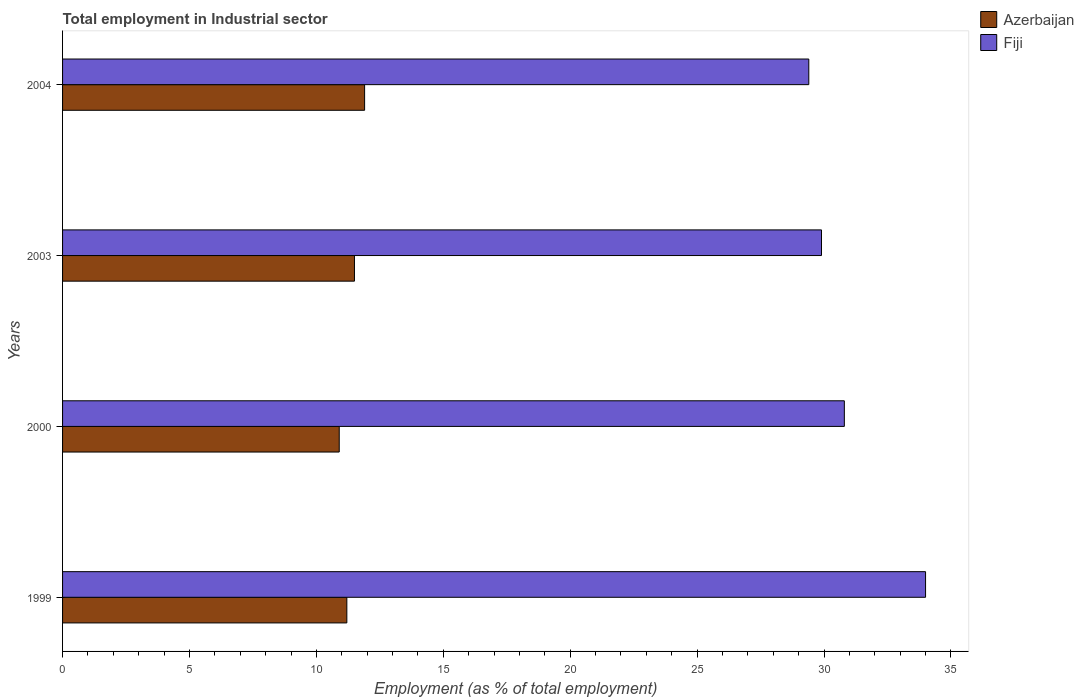How many different coloured bars are there?
Give a very brief answer. 2. Are the number of bars per tick equal to the number of legend labels?
Make the answer very short. Yes. Are the number of bars on each tick of the Y-axis equal?
Your answer should be compact. Yes. How many bars are there on the 1st tick from the bottom?
Offer a terse response. 2. In how many cases, is the number of bars for a given year not equal to the number of legend labels?
Your answer should be very brief. 0. What is the employment in industrial sector in Fiji in 2003?
Keep it short and to the point. 29.9. Across all years, what is the maximum employment in industrial sector in Fiji?
Offer a very short reply. 34. Across all years, what is the minimum employment in industrial sector in Fiji?
Keep it short and to the point. 29.4. What is the total employment in industrial sector in Fiji in the graph?
Provide a succinct answer. 124.1. What is the difference between the employment in industrial sector in Azerbaijan in 2000 and that in 2003?
Provide a succinct answer. -0.6. What is the difference between the employment in industrial sector in Azerbaijan in 2004 and the employment in industrial sector in Fiji in 1999?
Offer a terse response. -22.1. What is the average employment in industrial sector in Azerbaijan per year?
Provide a short and direct response. 11.37. In the year 2004, what is the difference between the employment in industrial sector in Fiji and employment in industrial sector in Azerbaijan?
Provide a succinct answer. 17.5. What is the ratio of the employment in industrial sector in Azerbaijan in 1999 to that in 2000?
Your answer should be very brief. 1.03. Is the employment in industrial sector in Azerbaijan in 2003 less than that in 2004?
Provide a succinct answer. Yes. Is the difference between the employment in industrial sector in Fiji in 1999 and 2004 greater than the difference between the employment in industrial sector in Azerbaijan in 1999 and 2004?
Give a very brief answer. Yes. What is the difference between the highest and the second highest employment in industrial sector in Fiji?
Keep it short and to the point. 3.2. What is the difference between the highest and the lowest employment in industrial sector in Azerbaijan?
Provide a short and direct response. 1. In how many years, is the employment in industrial sector in Azerbaijan greater than the average employment in industrial sector in Azerbaijan taken over all years?
Provide a succinct answer. 2. What does the 1st bar from the top in 2004 represents?
Offer a very short reply. Fiji. What does the 2nd bar from the bottom in 2004 represents?
Provide a short and direct response. Fiji. Are all the bars in the graph horizontal?
Ensure brevity in your answer.  Yes. How many years are there in the graph?
Provide a short and direct response. 4. What is the difference between two consecutive major ticks on the X-axis?
Provide a succinct answer. 5. Does the graph contain grids?
Provide a short and direct response. No. What is the title of the graph?
Your response must be concise. Total employment in Industrial sector. Does "Lithuania" appear as one of the legend labels in the graph?
Offer a terse response. No. What is the label or title of the X-axis?
Offer a terse response. Employment (as % of total employment). What is the label or title of the Y-axis?
Make the answer very short. Years. What is the Employment (as % of total employment) in Azerbaijan in 1999?
Offer a very short reply. 11.2. What is the Employment (as % of total employment) of Fiji in 1999?
Offer a terse response. 34. What is the Employment (as % of total employment) in Azerbaijan in 2000?
Provide a short and direct response. 10.9. What is the Employment (as % of total employment) in Fiji in 2000?
Ensure brevity in your answer.  30.8. What is the Employment (as % of total employment) in Fiji in 2003?
Your answer should be compact. 29.9. What is the Employment (as % of total employment) of Azerbaijan in 2004?
Offer a terse response. 11.9. What is the Employment (as % of total employment) in Fiji in 2004?
Your answer should be very brief. 29.4. Across all years, what is the maximum Employment (as % of total employment) of Azerbaijan?
Keep it short and to the point. 11.9. Across all years, what is the minimum Employment (as % of total employment) of Azerbaijan?
Your response must be concise. 10.9. Across all years, what is the minimum Employment (as % of total employment) of Fiji?
Give a very brief answer. 29.4. What is the total Employment (as % of total employment) in Azerbaijan in the graph?
Your answer should be compact. 45.5. What is the total Employment (as % of total employment) in Fiji in the graph?
Your answer should be compact. 124.1. What is the difference between the Employment (as % of total employment) of Fiji in 1999 and that in 2000?
Offer a very short reply. 3.2. What is the difference between the Employment (as % of total employment) of Fiji in 1999 and that in 2003?
Offer a very short reply. 4.1. What is the difference between the Employment (as % of total employment) in Fiji in 1999 and that in 2004?
Your answer should be very brief. 4.6. What is the difference between the Employment (as % of total employment) in Azerbaijan in 2000 and that in 2003?
Ensure brevity in your answer.  -0.6. What is the difference between the Employment (as % of total employment) in Fiji in 2000 and that in 2003?
Offer a very short reply. 0.9. What is the difference between the Employment (as % of total employment) of Fiji in 2000 and that in 2004?
Offer a very short reply. 1.4. What is the difference between the Employment (as % of total employment) of Azerbaijan in 1999 and the Employment (as % of total employment) of Fiji in 2000?
Provide a short and direct response. -19.6. What is the difference between the Employment (as % of total employment) of Azerbaijan in 1999 and the Employment (as % of total employment) of Fiji in 2003?
Your answer should be compact. -18.7. What is the difference between the Employment (as % of total employment) of Azerbaijan in 1999 and the Employment (as % of total employment) of Fiji in 2004?
Make the answer very short. -18.2. What is the difference between the Employment (as % of total employment) of Azerbaijan in 2000 and the Employment (as % of total employment) of Fiji in 2004?
Your response must be concise. -18.5. What is the difference between the Employment (as % of total employment) of Azerbaijan in 2003 and the Employment (as % of total employment) of Fiji in 2004?
Give a very brief answer. -17.9. What is the average Employment (as % of total employment) of Azerbaijan per year?
Give a very brief answer. 11.38. What is the average Employment (as % of total employment) in Fiji per year?
Your response must be concise. 31.02. In the year 1999, what is the difference between the Employment (as % of total employment) of Azerbaijan and Employment (as % of total employment) of Fiji?
Your response must be concise. -22.8. In the year 2000, what is the difference between the Employment (as % of total employment) in Azerbaijan and Employment (as % of total employment) in Fiji?
Provide a short and direct response. -19.9. In the year 2003, what is the difference between the Employment (as % of total employment) of Azerbaijan and Employment (as % of total employment) of Fiji?
Offer a terse response. -18.4. In the year 2004, what is the difference between the Employment (as % of total employment) in Azerbaijan and Employment (as % of total employment) in Fiji?
Give a very brief answer. -17.5. What is the ratio of the Employment (as % of total employment) in Azerbaijan in 1999 to that in 2000?
Offer a very short reply. 1.03. What is the ratio of the Employment (as % of total employment) of Fiji in 1999 to that in 2000?
Make the answer very short. 1.1. What is the ratio of the Employment (as % of total employment) of Azerbaijan in 1999 to that in 2003?
Ensure brevity in your answer.  0.97. What is the ratio of the Employment (as % of total employment) in Fiji in 1999 to that in 2003?
Your response must be concise. 1.14. What is the ratio of the Employment (as % of total employment) of Azerbaijan in 1999 to that in 2004?
Your answer should be compact. 0.94. What is the ratio of the Employment (as % of total employment) of Fiji in 1999 to that in 2004?
Make the answer very short. 1.16. What is the ratio of the Employment (as % of total employment) of Azerbaijan in 2000 to that in 2003?
Ensure brevity in your answer.  0.95. What is the ratio of the Employment (as % of total employment) of Fiji in 2000 to that in 2003?
Your response must be concise. 1.03. What is the ratio of the Employment (as % of total employment) in Azerbaijan in 2000 to that in 2004?
Ensure brevity in your answer.  0.92. What is the ratio of the Employment (as % of total employment) of Fiji in 2000 to that in 2004?
Provide a succinct answer. 1.05. What is the ratio of the Employment (as % of total employment) of Azerbaijan in 2003 to that in 2004?
Give a very brief answer. 0.97. What is the difference between the highest and the second highest Employment (as % of total employment) in Azerbaijan?
Provide a short and direct response. 0.4. What is the difference between the highest and the second highest Employment (as % of total employment) of Fiji?
Keep it short and to the point. 3.2. What is the difference between the highest and the lowest Employment (as % of total employment) in Fiji?
Offer a terse response. 4.6. 